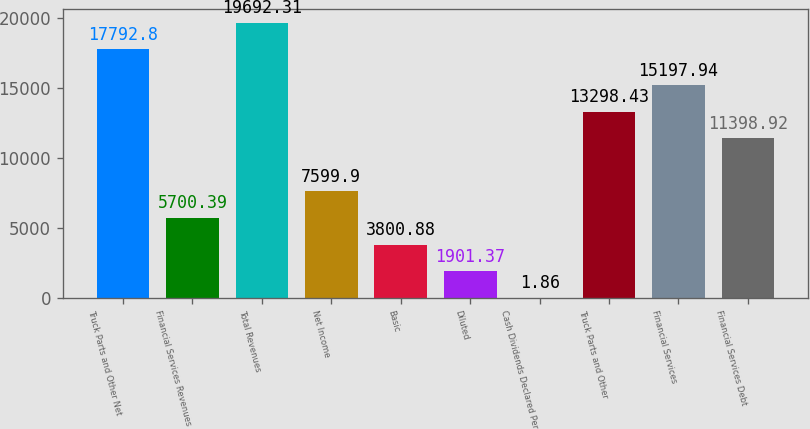Convert chart. <chart><loc_0><loc_0><loc_500><loc_500><bar_chart><fcel>Truck Parts and Other Net<fcel>Financial Services Revenues<fcel>Total Revenues<fcel>Net Income<fcel>Basic<fcel>Diluted<fcel>Cash Dividends Declared Per<fcel>Truck Parts and Other<fcel>Financial Services<fcel>Financial Services Debt<nl><fcel>17792.8<fcel>5700.39<fcel>19692.3<fcel>7599.9<fcel>3800.88<fcel>1901.37<fcel>1.86<fcel>13298.4<fcel>15197.9<fcel>11398.9<nl></chart> 